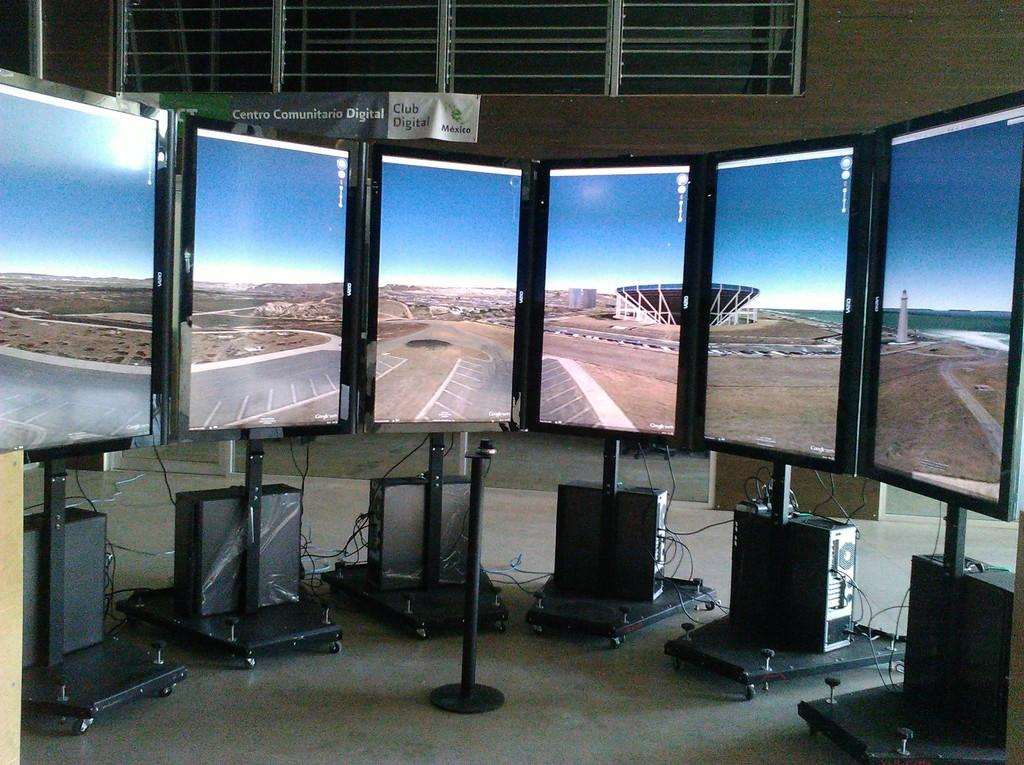What type of equipment can be seen in the image? There are monitors on stands and electrical devices in the image. What is the primary support structure in the image? There is a pole in the image. What part of the room is visible in the image? The floor is visible in the image. What might be used for connecting or powering the electrical devices? There are cables in the image. What can be seen in the background of the image? There is a banner, a wall, and windows in the background of the image. What type of sweater is the moon wearing in the image? There is no moon or sweater present in the image. How does the fog affect the visibility of the electrical devices in the image? There is no fog present in the image; the visibility of the electrical devices is clear. 